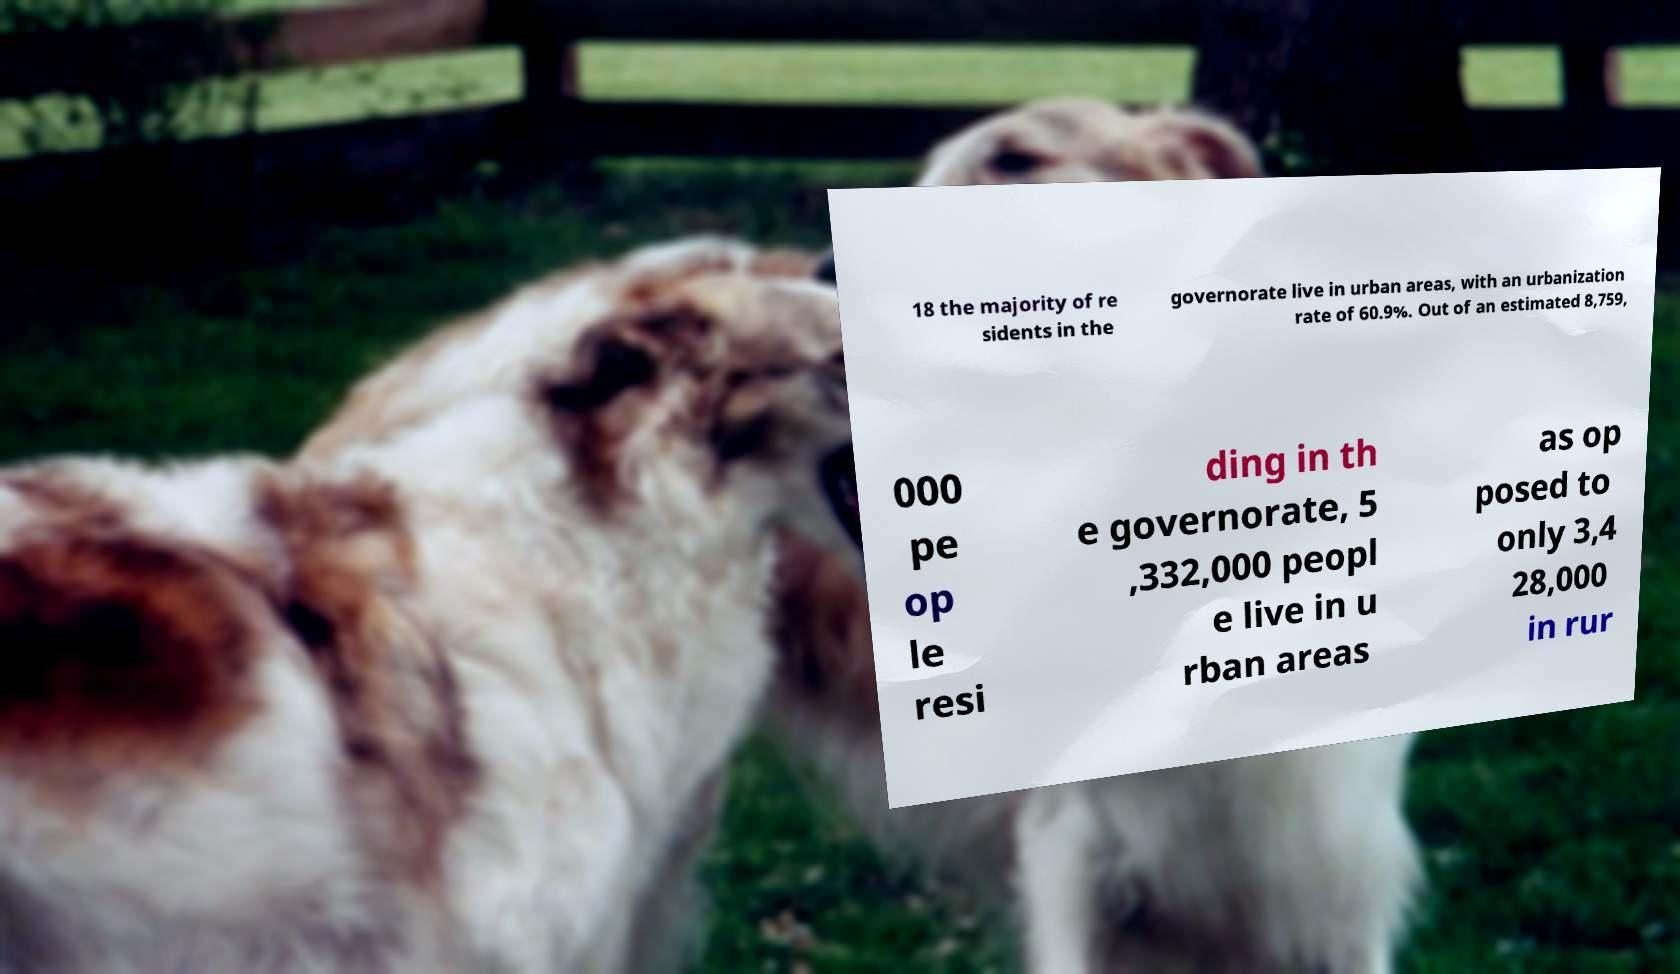Can you read and provide the text displayed in the image?This photo seems to have some interesting text. Can you extract and type it out for me? 18 the majority of re sidents in the governorate live in urban areas, with an urbanization rate of 60.9%. Out of an estimated 8,759, 000 pe op le resi ding in th e governorate, 5 ,332,000 peopl e live in u rban areas as op posed to only 3,4 28,000 in rur 